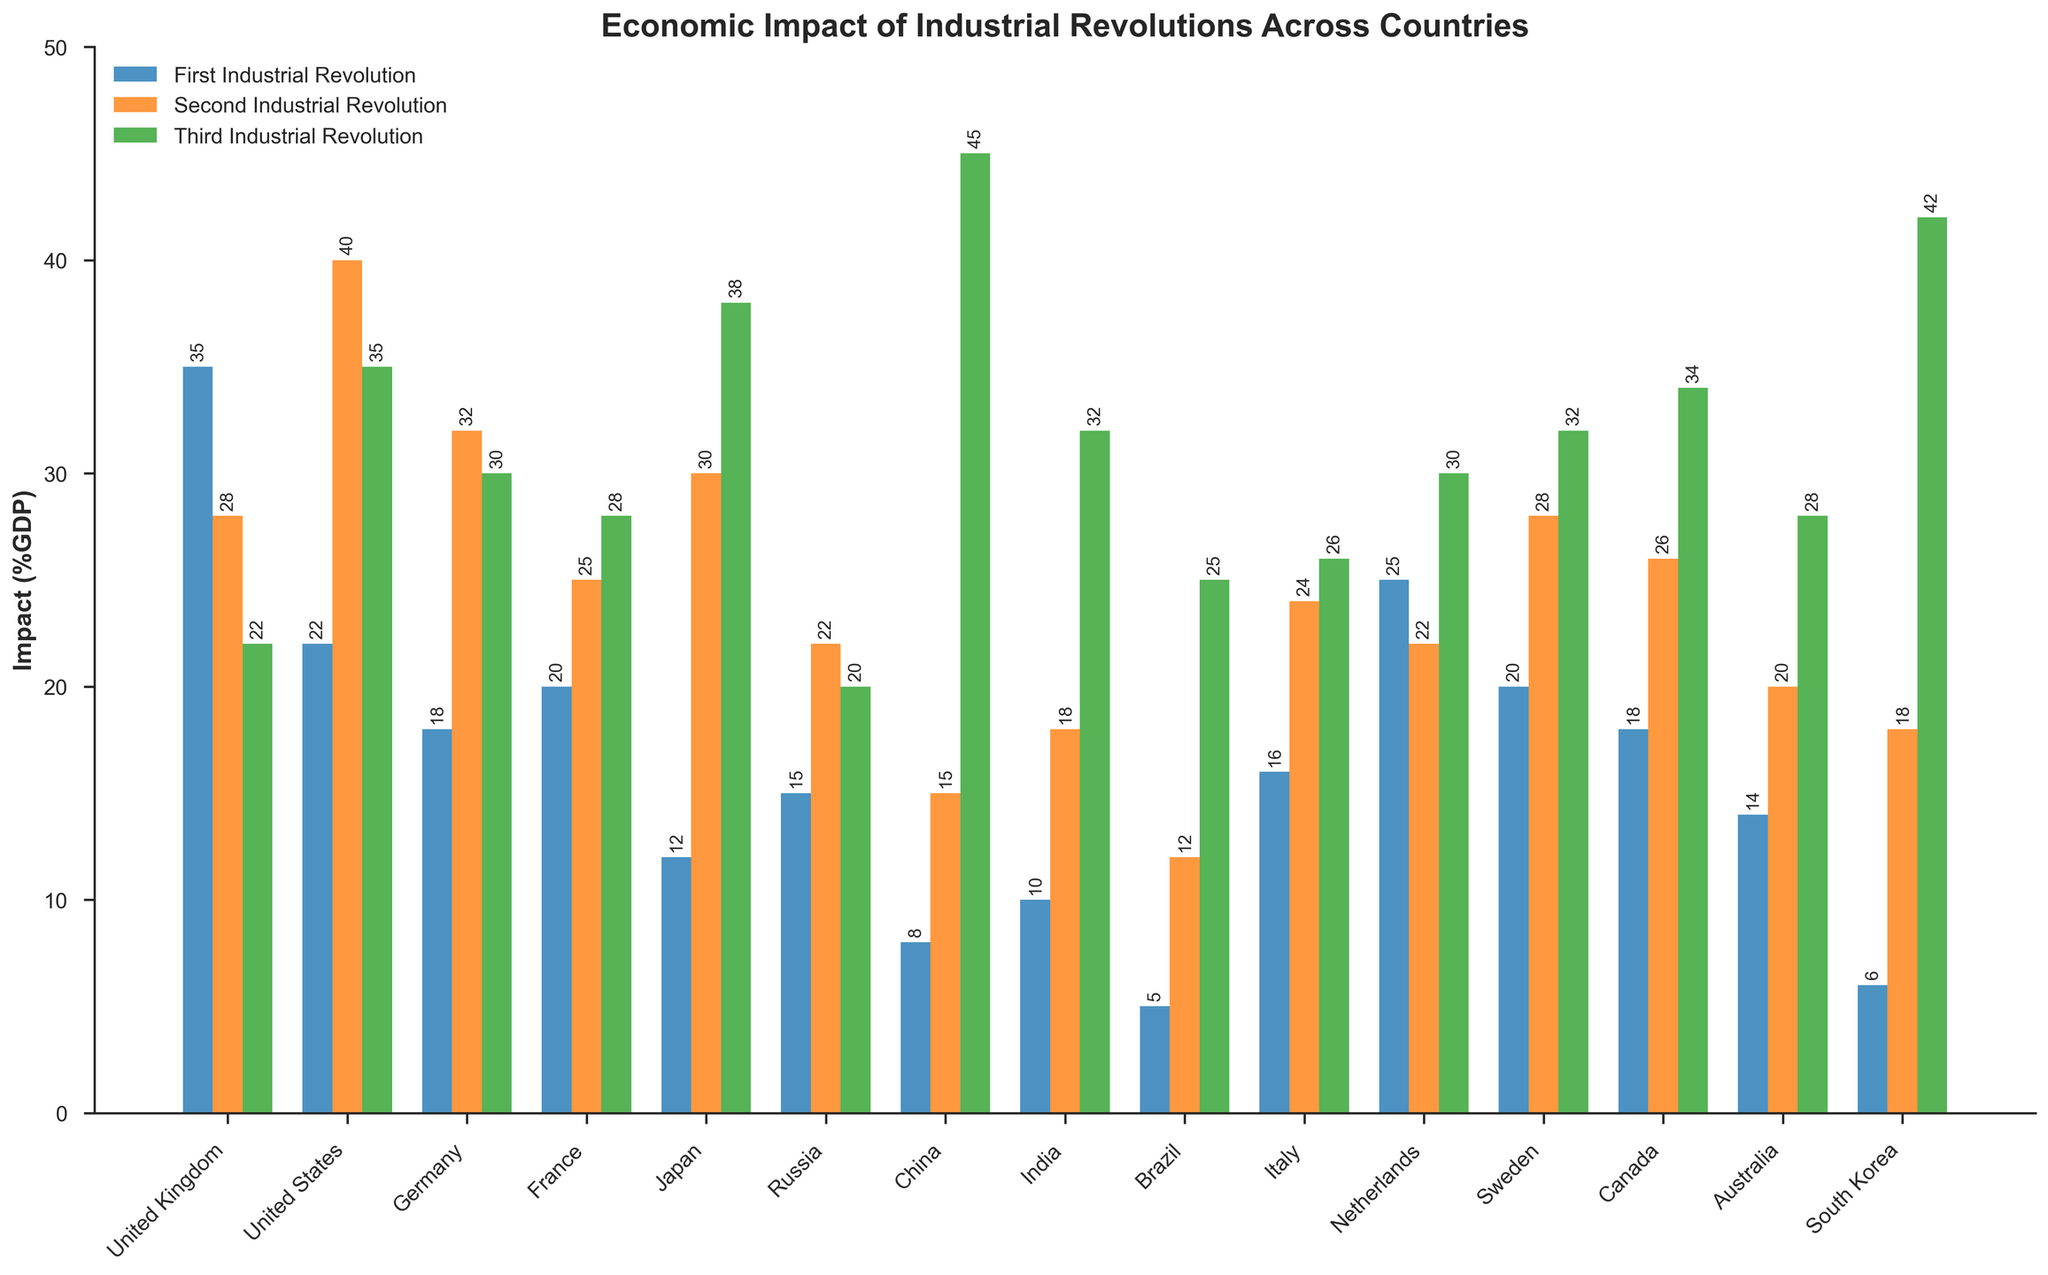Which country had the highest economic impact from the Third Industrial Revolution? To determine this, we look for the country with the tallest green bar, which is China at 45% GDP.
Answer: China Compare the impact of the First Industrial Revolution and the Third Industrial Revolution in the United States. For the United States, the blue bar (First Industrial Revolution) is at 22% and the green bar (Third Industrial Revolution) is at 35%. The Third Industrial Revolution has a higher impact.
Answer: The Third Industrial Revolution had a higher impact What is the sum of the economic impacts from all three industrial revolutions in Germany? Add the heights of the blue, orange, and green bars for Germany: 18% (First) + 32% (Second) + 30% (Third) = 80%.
Answer: 80% Which country had the smallest impact from the First Industrial Revolution, and what was the percentage? The smallest blue bar represents Brazil at 5% GDP.
Answer: Brazil, 5% How much greater was the impact of the Second Industrial Revolution compared to the First Industrial Revolution in Japan? Subtract the blue bar (First Industrial Revolution) from the orange bar (Second Industrial Revolution) for Japan: 30% - 12% = 18%.
Answer: 18% Which countries had a higher impact from the Second Industrial Revolution than the First Industrial Revolution by exactly 10%? We need to identify countries where the orange bar exceeds the blue bar by 10%. For Sweden, it is 28% - 20% = 8%, and for Australia, it is 20% - 14% = 6%. None fits the 10% criterion directly; only approximations can be made.
Answer: None What is the average economic impact of the Third Industrial Revolution across all countries? Sum the green bars and divide by the number of countries: (22+35+30+28+38+20+45+32+25+26+30+32+34+28+42)/15 = 435/15 = 29%.
Answer: 29% By how much did the economic impact of the Third Industrial Revolution exceed that of the First Industrial Revolution in China? Subtract the blue bar (First Industrial Revolution) from the green bar (Third Industrial Revolution) for China: 45% - 8% = 37%.
Answer: 37% Which country experienced the most considerable change in economic impact between the First and Second Industrial Revolutions? Evaluate the height difference between the blue and orange bars for each country. The United States has a change of 40% - 22% = 18%.
Answer: United States 